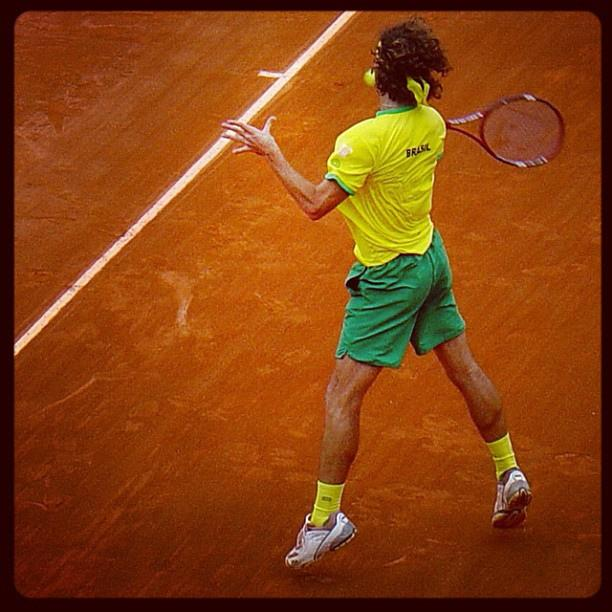What is this man doing?

Choices:
A) return ball
B) quit
C) loving
D) serving return ball 